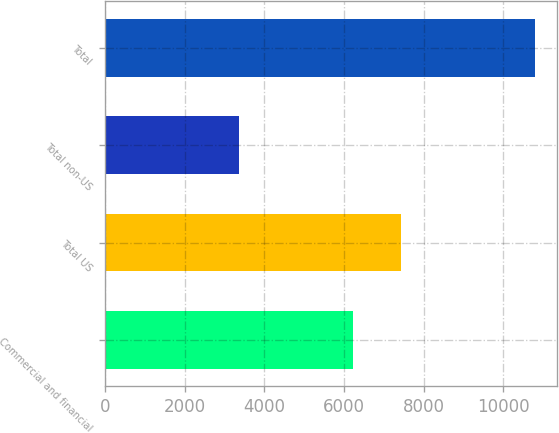Convert chart. <chart><loc_0><loc_0><loc_500><loc_500><bar_chart><fcel>Commercial and financial<fcel>Total US<fcel>Total non-US<fcel>Total<nl><fcel>6239<fcel>7433<fcel>3375<fcel>10808<nl></chart> 